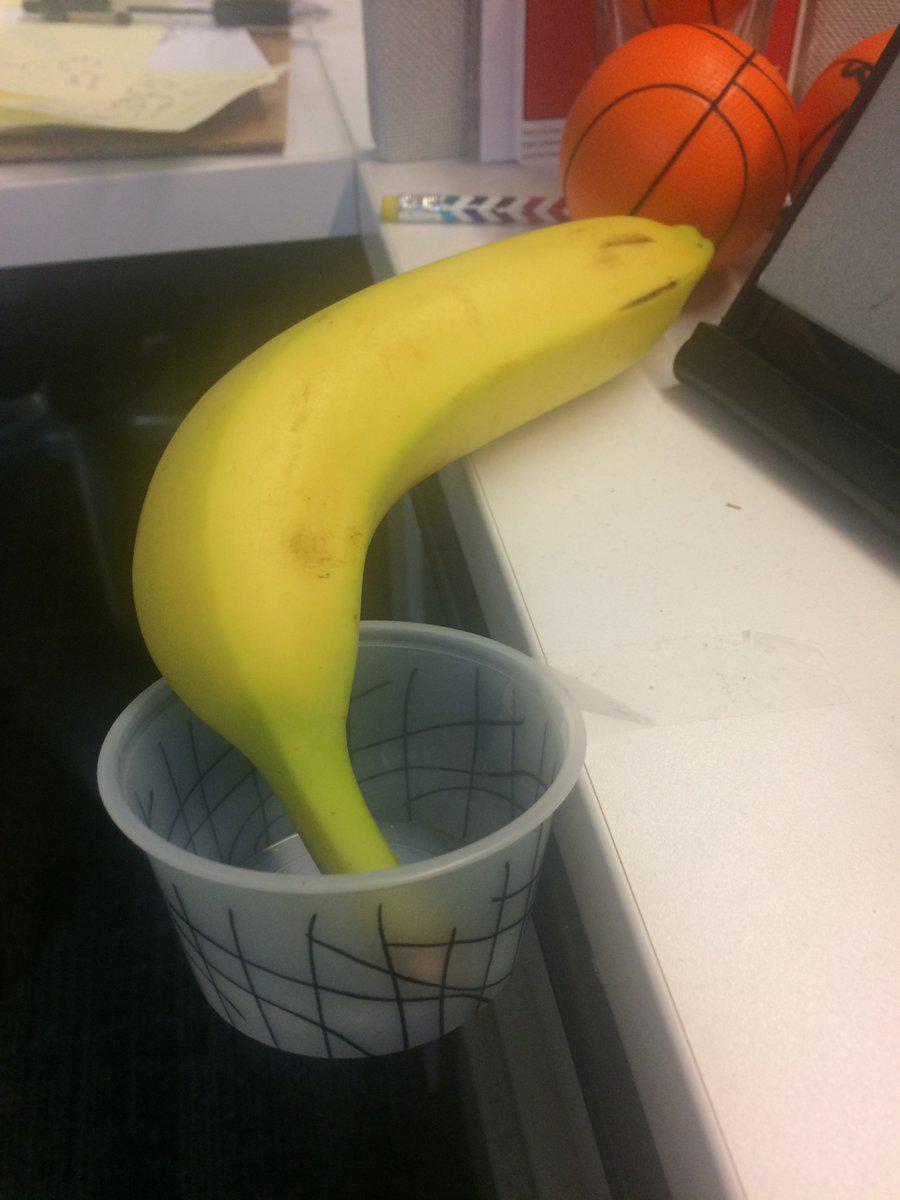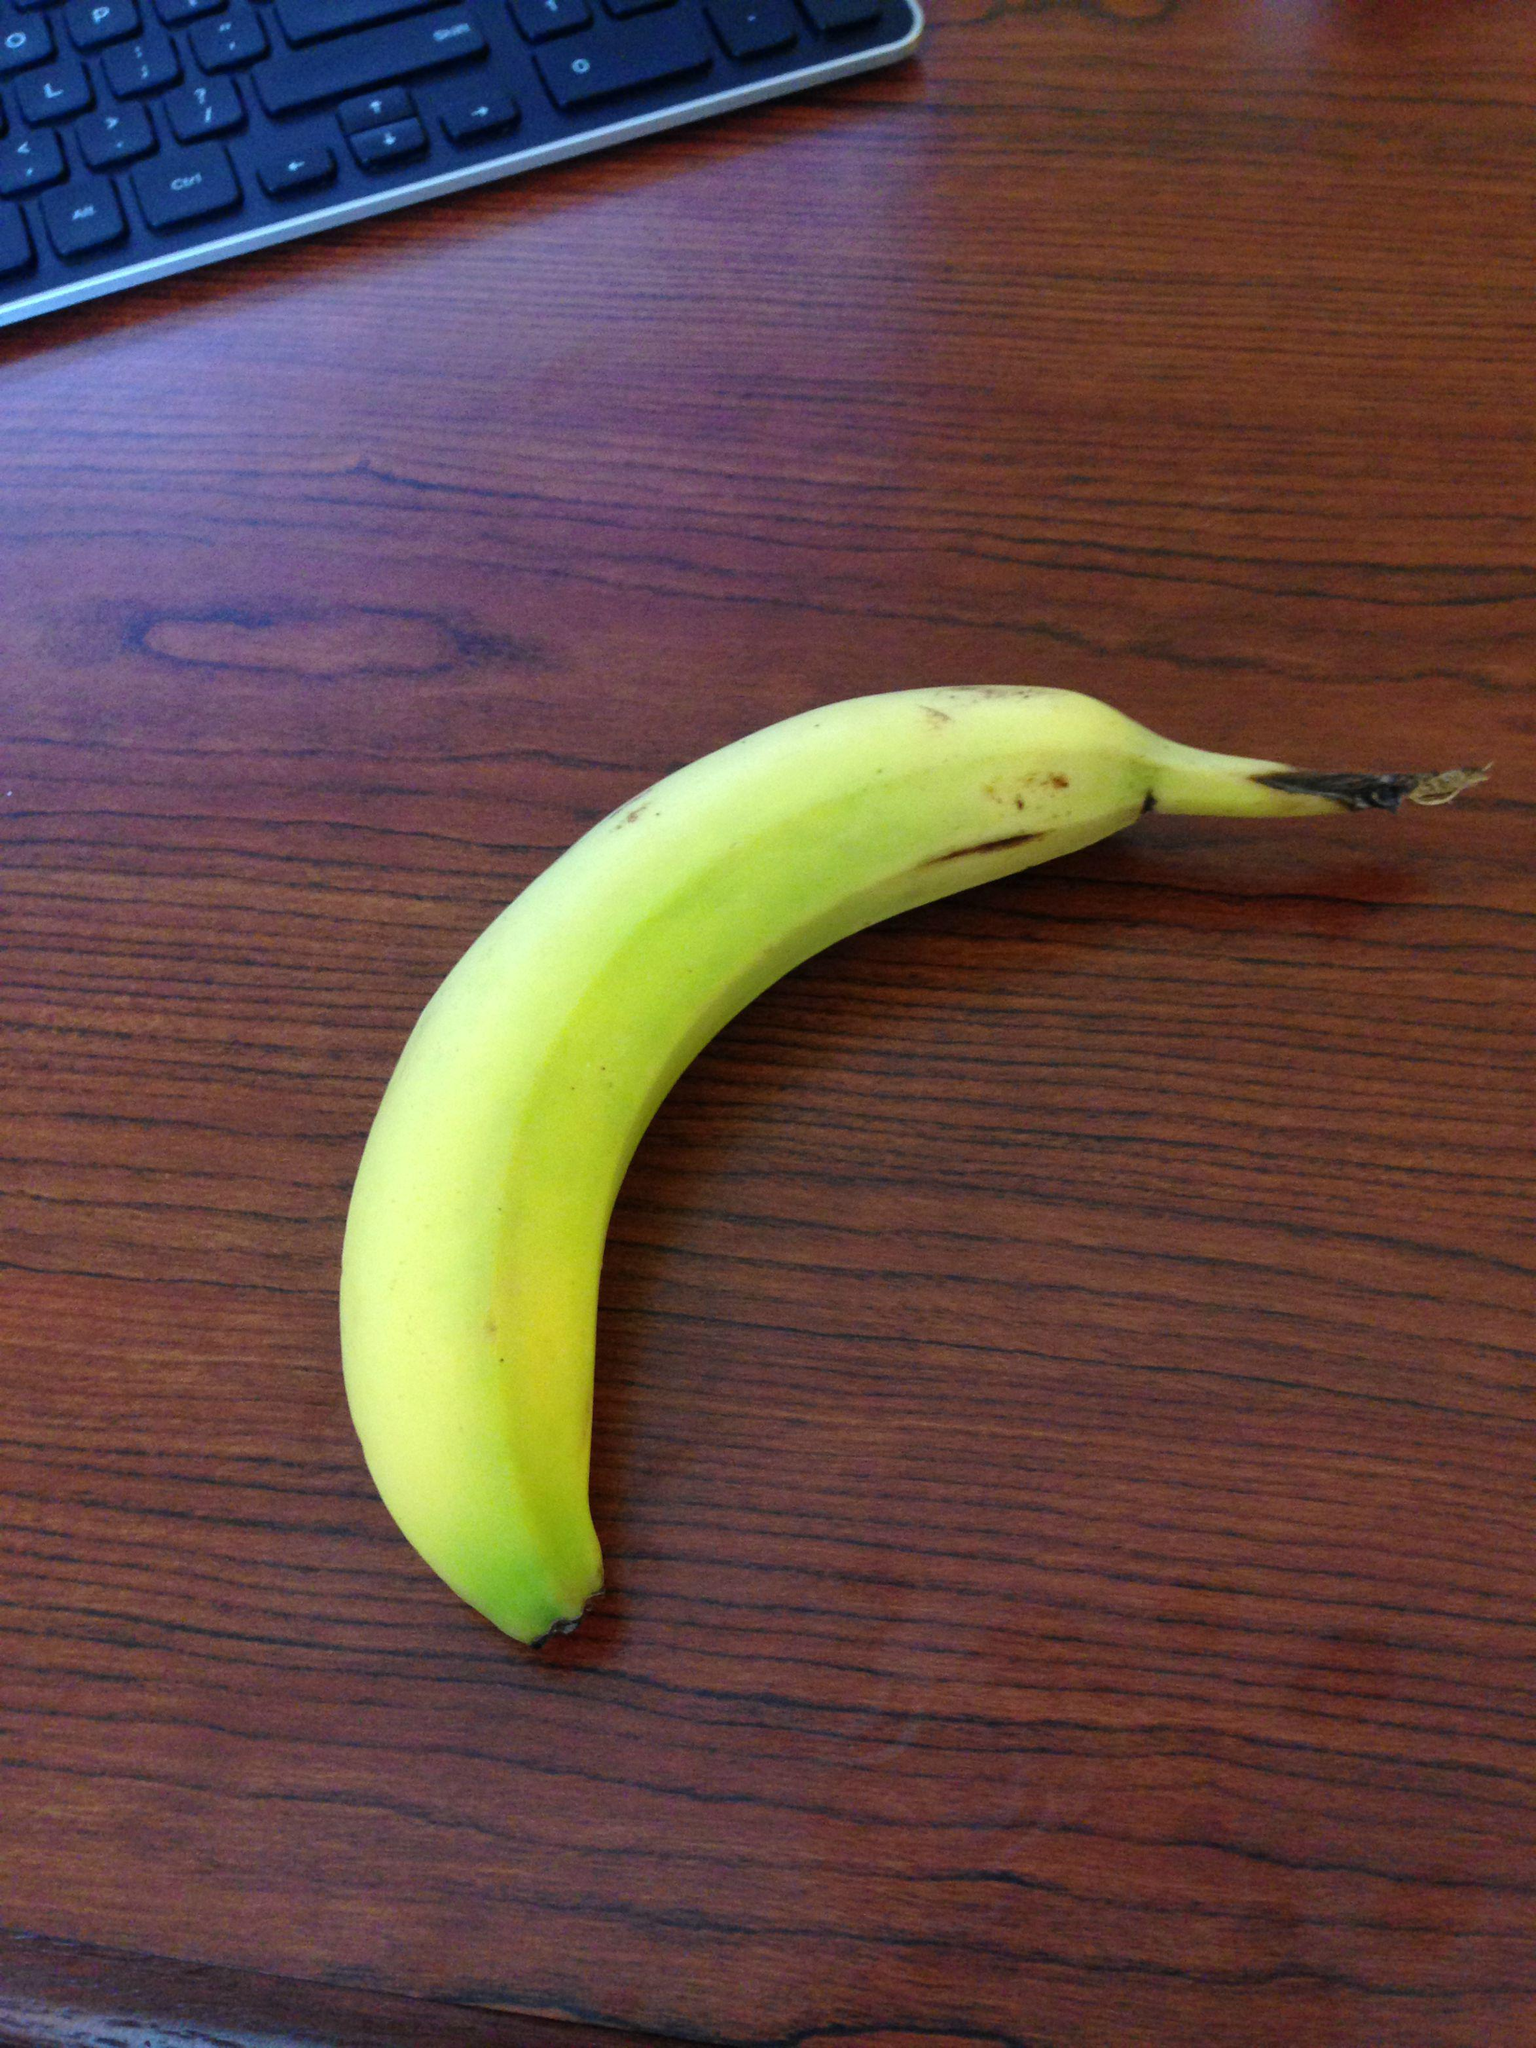The first image is the image on the left, the second image is the image on the right. Examine the images to the left and right. Is the description "A banana is on a reddish-brown woodgrain surface in the right image, and a banana is by a cup-like container in the left image." accurate? Answer yes or no. Yes. The first image is the image on the left, the second image is the image on the right. For the images shown, is this caption "Two bananas are sitting on a desk, and at least one of them is sitting beside a piece of paper." true? Answer yes or no. No. 